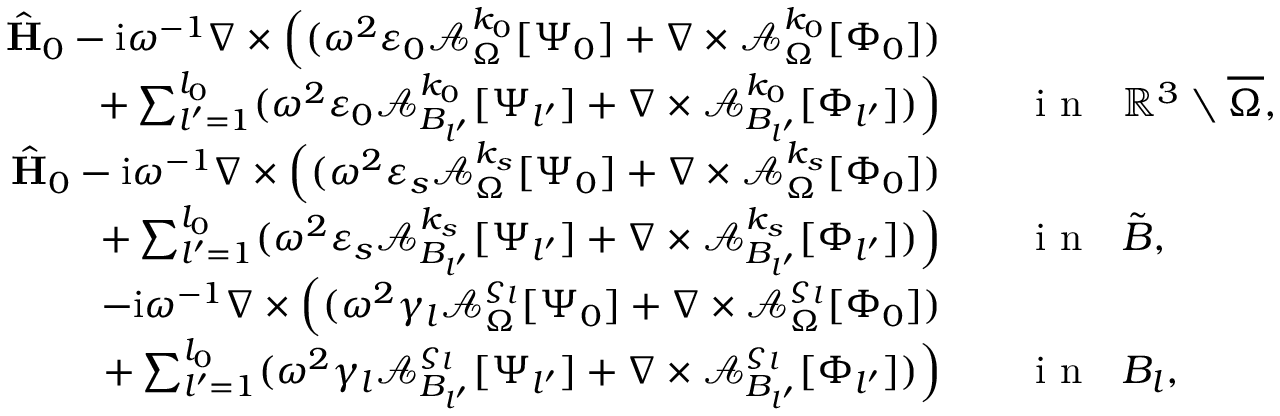<formula> <loc_0><loc_0><loc_500><loc_500>\begin{array} { r l } { \hat { H } _ { 0 } - i \omega ^ { - 1 } \nabla \times \left ( ( \omega ^ { 2 } \varepsilon _ { 0 } \mathcal { A } _ { \Omega } ^ { k _ { 0 } } [ \Psi _ { 0 } ] + \nabla \times \mathcal { A } _ { \Omega } ^ { k _ { 0 } } [ \Phi _ { 0 } ] ) } \\ { + \sum _ { l ^ { \prime } = 1 } ^ { l _ { 0 } } ( \omega ^ { 2 } \varepsilon _ { 0 } \mathcal { A } _ { B _ { l ^ { \prime } } } ^ { k _ { 0 } } [ \Psi _ { l ^ { \prime } } ] + \nabla \times \mathcal { A } _ { B _ { l ^ { \prime } } } ^ { k _ { 0 } } [ \Phi _ { l ^ { \prime } } ] ) \right ) } & \quad i n \quad m a t h b b { R } ^ { 3 } \ \overline { \Omega } , } \\ { \hat { H } _ { 0 } - i \omega ^ { - 1 } \nabla \times \left ( ( \omega ^ { 2 } \varepsilon _ { s } \mathcal { A } _ { \Omega } ^ { k _ { s } } [ \Psi _ { 0 } ] + \nabla \times \mathcal { A } _ { \Omega } ^ { k _ { s } } [ \Phi _ { 0 } ] ) } \\ { + \sum _ { l ^ { \prime } = 1 } ^ { l _ { 0 } } ( \omega ^ { 2 } \varepsilon _ { s } \mathcal { A } _ { B _ { l ^ { \prime } } } ^ { k _ { s } } [ \Psi _ { l ^ { \prime } } ] + \nabla \times \mathcal { A } _ { B _ { l ^ { \prime } } } ^ { k _ { s } } [ \Phi _ { l ^ { \prime } } ] ) \right ) } & \quad i n \quad t i l d e { B } , } \\ { - i \omega ^ { - 1 } \nabla \times \left ( ( \omega ^ { 2 } \gamma _ { l } \mathcal { A } _ { \Omega } ^ { \varsigma _ { l } } [ \Psi _ { 0 } ] + \nabla \times \mathcal { A } _ { \Omega } ^ { \varsigma _ { l } } [ \Phi _ { 0 } ] ) } \\ { + \sum _ { l ^ { \prime } = 1 } ^ { l _ { 0 } } ( \omega ^ { 2 } \gamma _ { l } \mathcal { A } _ { B _ { l ^ { \prime } } } ^ { \varsigma _ { l } } [ \Psi _ { l ^ { \prime } } ] + \nabla \times \mathcal { A } _ { B _ { l ^ { \prime } } } ^ { \varsigma _ { l } } [ \Phi _ { l ^ { \prime } } ] ) \right ) } & \quad i n \ \ B _ { l } , } \end{array}</formula> 